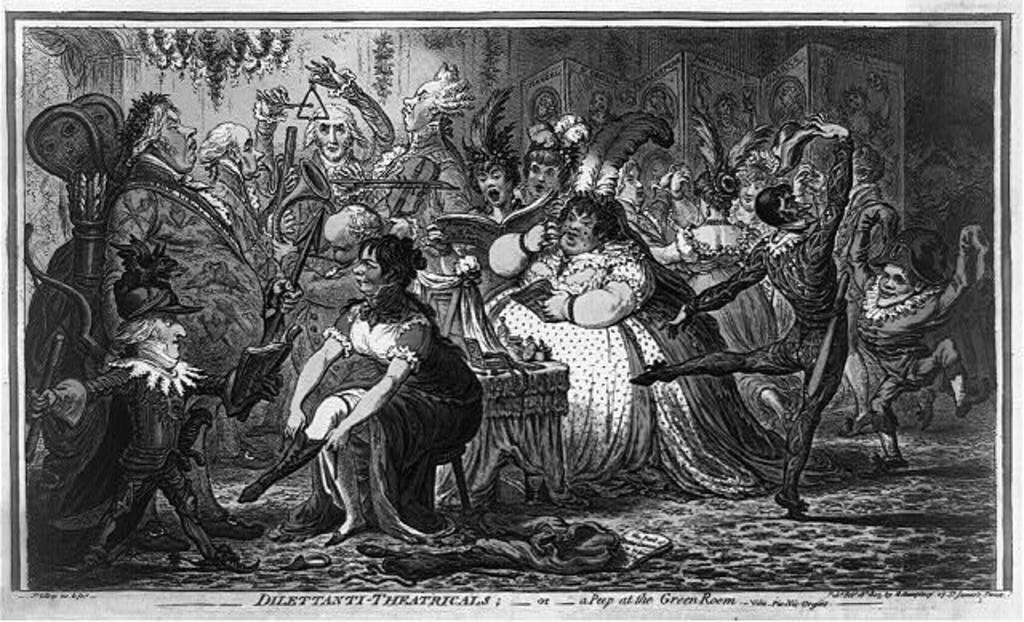Describe this image in one or two sentences. In this image there is a painting of few persons. A woman is sitting on a stool. Behind there is a table having few objects on it. Few persons are holding books. Few persons are holding musical instruments in their hands. Few persons are dancing on the floor. Left side there is a person wearing a cap and she is holding a stick in his hand. 